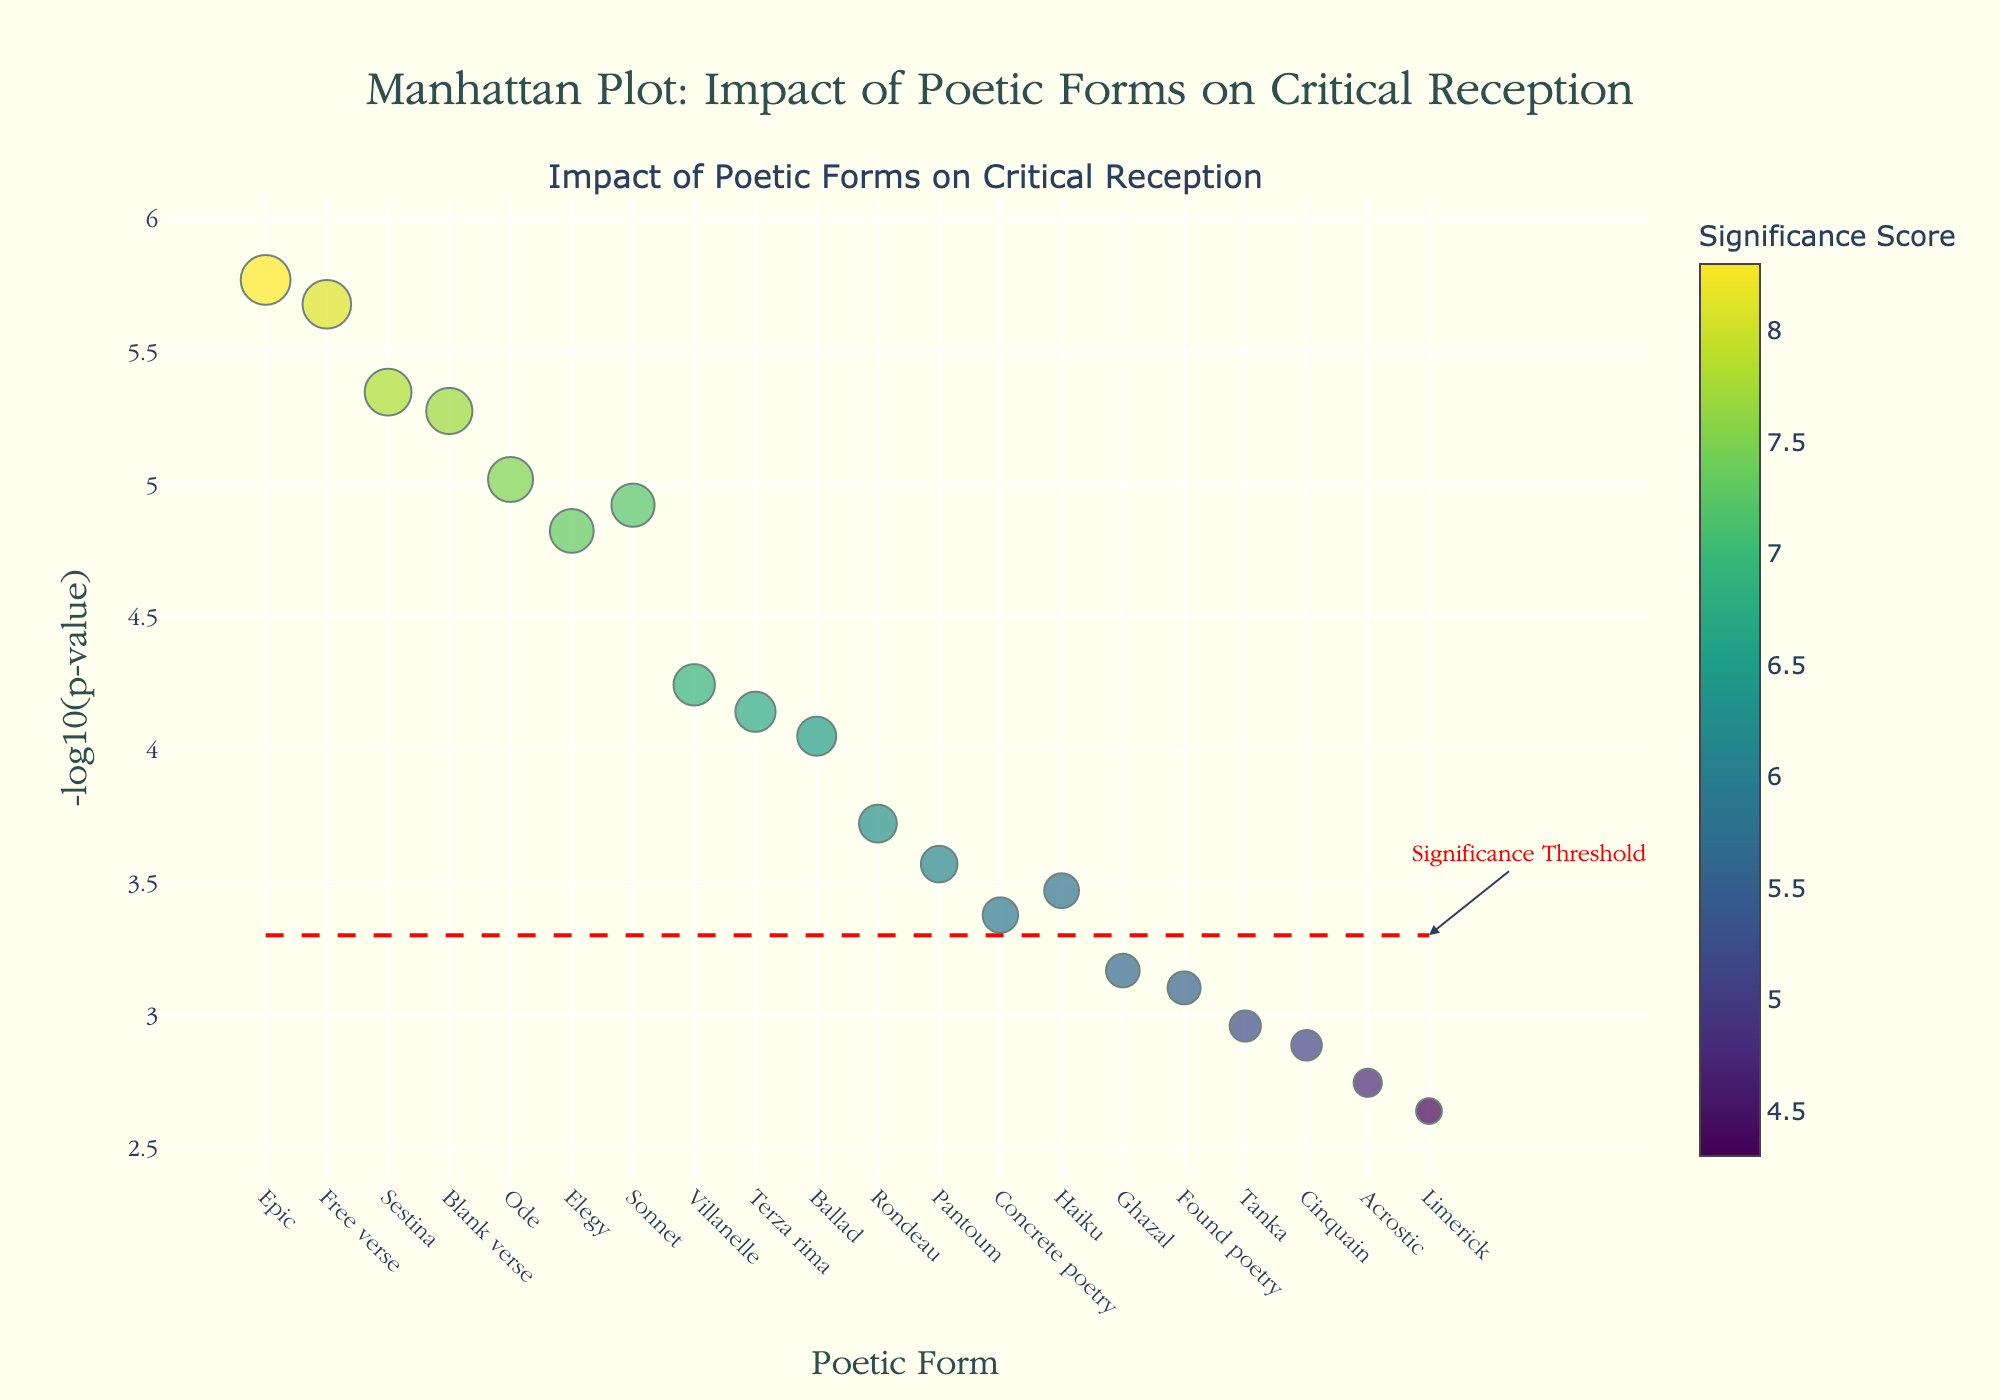What is the title of the figure? The figure has a distinct title placed at the top. The title reads "Manhattan Plot: Impact of Poetic Forms on Critical Reception".
Answer: Manhattan Plot: Impact of Poetic Forms on Critical Reception Which poetic form has the highest -log10(p-value)? By examining the y-axis for the highest value, it can be observed that the "Epic" form has the highest -log10(p-value).
Answer: Epic How many poetic forms are represented in the plot? Count the number of distinct points on the x-axis, which represent different poetic forms. There are 20 points, hence 20 poetic forms.
Answer: 20 What color scheme is used to represent the significance scores in the plot? The plot uses a colorscale to represent significance scores, with varying shades from the "Viridis" colorscale.
Answer: Viridis Which poetic forms have a significance score greater than 7.5? Look for the markers with a color above 7.5 on the colorbar. The poetic forms are "Epic", "Free verse", "Ode", "Sestina", "Blank verse", and "Elegy".
Answer: Epic, Free verse, Ode, Sestina, Blank verse, Elegy What is the significance threshold line's y-value in the plot? The plot includes a dashed red line as the significance threshold. The y-value of this line is at -log10(5e-4). Calculate -log10(5e-4) which equals approximately ~3.30.
Answer: ~3.30 Which poetic form has the smallest significance score but still above the threshold line? Identify markers above the threshold line and find the one with the smallest significance score. "Terza rima" has the smallest significance score of 6.7 that is still above the threshold.
Answer: Terza rima Compare the significance scores of Haiku and Ghazal. Which one is higher and by how much? Look at the color and size of the markers for Haiku and Ghazal. Haiku has a score of 5.8 and Ghazal has a score of 5.6. The difference is 5.8 - 5.6 = 0.2.
Answer: Haiku by 0.2 How many poetic forms fall below the significance threshold line? Count the number of points below the red dashed line. There are 6 poetic forms below this line.
Answer: 6 What is the average -log10(p-value) for the forms: Sonnet, Haiku, and Blank verse? Calculate the -log10(p-value) for each: Sonnet (4.92), Haiku (3.47), Blank verse (5.28). Average = (4.92 + 3.47 + 5.28) / 3 ≈ 4.56.
Answer: ~4.56 